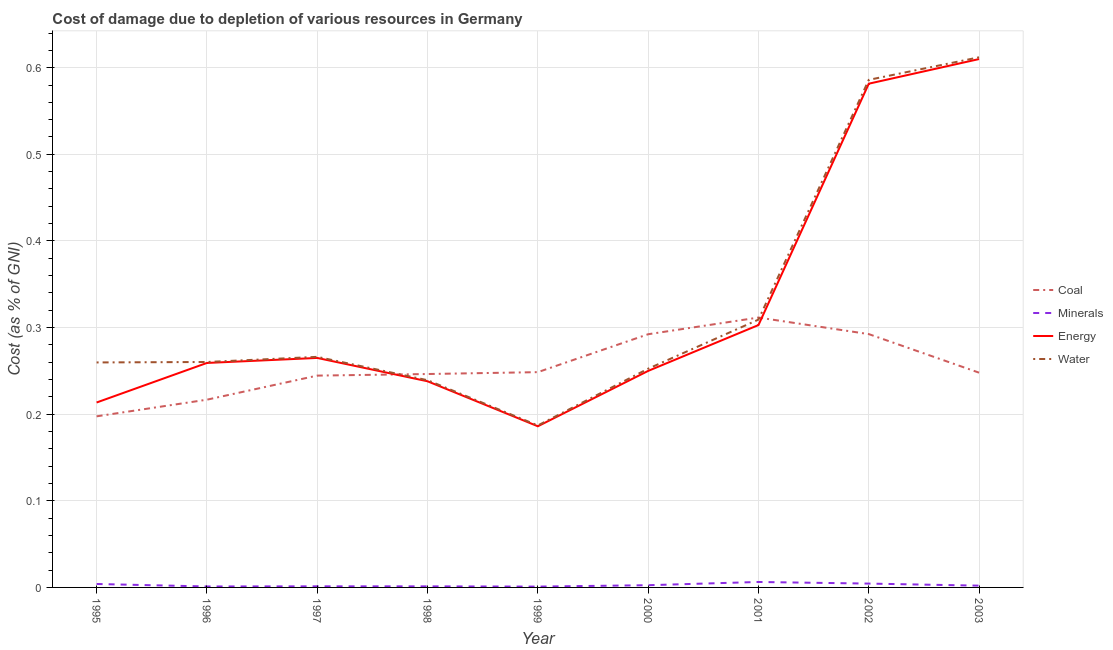Is the number of lines equal to the number of legend labels?
Make the answer very short. Yes. What is the cost of damage due to depletion of energy in 2001?
Your answer should be very brief. 0.3. Across all years, what is the maximum cost of damage due to depletion of water?
Your response must be concise. 0.61. Across all years, what is the minimum cost of damage due to depletion of coal?
Provide a short and direct response. 0.2. In which year was the cost of damage due to depletion of coal maximum?
Give a very brief answer. 2001. What is the total cost of damage due to depletion of coal in the graph?
Your answer should be compact. 2.3. What is the difference between the cost of damage due to depletion of water in 2001 and that in 2002?
Provide a short and direct response. -0.28. What is the difference between the cost of damage due to depletion of coal in 1997 and the cost of damage due to depletion of water in 1995?
Ensure brevity in your answer.  -0.02. What is the average cost of damage due to depletion of coal per year?
Your answer should be very brief. 0.26. In the year 1997, what is the difference between the cost of damage due to depletion of water and cost of damage due to depletion of energy?
Provide a succinct answer. 0. What is the ratio of the cost of damage due to depletion of coal in 1996 to that in 1997?
Keep it short and to the point. 0.89. Is the cost of damage due to depletion of coal in 1995 less than that in 2002?
Give a very brief answer. Yes. Is the difference between the cost of damage due to depletion of water in 2000 and 2003 greater than the difference between the cost of damage due to depletion of minerals in 2000 and 2003?
Offer a terse response. No. What is the difference between the highest and the second highest cost of damage due to depletion of water?
Your response must be concise. 0.03. What is the difference between the highest and the lowest cost of damage due to depletion of coal?
Your answer should be very brief. 0.11. In how many years, is the cost of damage due to depletion of minerals greater than the average cost of damage due to depletion of minerals taken over all years?
Your response must be concise. 3. Is the sum of the cost of damage due to depletion of energy in 2002 and 2003 greater than the maximum cost of damage due to depletion of minerals across all years?
Your answer should be very brief. Yes. Is it the case that in every year, the sum of the cost of damage due to depletion of water and cost of damage due to depletion of minerals is greater than the sum of cost of damage due to depletion of energy and cost of damage due to depletion of coal?
Keep it short and to the point. Yes. Is it the case that in every year, the sum of the cost of damage due to depletion of coal and cost of damage due to depletion of minerals is greater than the cost of damage due to depletion of energy?
Your answer should be compact. No. Does the cost of damage due to depletion of coal monotonically increase over the years?
Your answer should be very brief. No. How many lines are there?
Make the answer very short. 4. What is the difference between two consecutive major ticks on the Y-axis?
Make the answer very short. 0.1. Are the values on the major ticks of Y-axis written in scientific E-notation?
Provide a short and direct response. No. Does the graph contain grids?
Your response must be concise. Yes. Where does the legend appear in the graph?
Your answer should be very brief. Center right. How many legend labels are there?
Give a very brief answer. 4. How are the legend labels stacked?
Offer a very short reply. Vertical. What is the title of the graph?
Your answer should be very brief. Cost of damage due to depletion of various resources in Germany . Does "Social Insurance" appear as one of the legend labels in the graph?
Your answer should be very brief. No. What is the label or title of the X-axis?
Ensure brevity in your answer.  Year. What is the label or title of the Y-axis?
Make the answer very short. Cost (as % of GNI). What is the Cost (as % of GNI) of Coal in 1995?
Ensure brevity in your answer.  0.2. What is the Cost (as % of GNI) of Minerals in 1995?
Ensure brevity in your answer.  0. What is the Cost (as % of GNI) in Energy in 1995?
Your response must be concise. 0.21. What is the Cost (as % of GNI) of Water in 1995?
Your response must be concise. 0.26. What is the Cost (as % of GNI) of Coal in 1996?
Provide a short and direct response. 0.22. What is the Cost (as % of GNI) of Minerals in 1996?
Ensure brevity in your answer.  0. What is the Cost (as % of GNI) in Energy in 1996?
Offer a terse response. 0.26. What is the Cost (as % of GNI) in Water in 1996?
Ensure brevity in your answer.  0.26. What is the Cost (as % of GNI) in Coal in 1997?
Ensure brevity in your answer.  0.24. What is the Cost (as % of GNI) of Minerals in 1997?
Provide a succinct answer. 0. What is the Cost (as % of GNI) of Energy in 1997?
Offer a terse response. 0.26. What is the Cost (as % of GNI) in Water in 1997?
Your answer should be very brief. 0.27. What is the Cost (as % of GNI) of Coal in 1998?
Your answer should be compact. 0.25. What is the Cost (as % of GNI) of Minerals in 1998?
Provide a short and direct response. 0. What is the Cost (as % of GNI) in Energy in 1998?
Give a very brief answer. 0.24. What is the Cost (as % of GNI) in Water in 1998?
Give a very brief answer. 0.24. What is the Cost (as % of GNI) of Coal in 1999?
Your response must be concise. 0.25. What is the Cost (as % of GNI) in Minerals in 1999?
Provide a succinct answer. 0. What is the Cost (as % of GNI) of Energy in 1999?
Your answer should be very brief. 0.19. What is the Cost (as % of GNI) of Water in 1999?
Your answer should be very brief. 0.19. What is the Cost (as % of GNI) of Coal in 2000?
Offer a terse response. 0.29. What is the Cost (as % of GNI) of Minerals in 2000?
Ensure brevity in your answer.  0. What is the Cost (as % of GNI) of Energy in 2000?
Offer a very short reply. 0.25. What is the Cost (as % of GNI) of Water in 2000?
Make the answer very short. 0.25. What is the Cost (as % of GNI) in Coal in 2001?
Ensure brevity in your answer.  0.31. What is the Cost (as % of GNI) of Minerals in 2001?
Your response must be concise. 0.01. What is the Cost (as % of GNI) in Energy in 2001?
Give a very brief answer. 0.3. What is the Cost (as % of GNI) in Water in 2001?
Make the answer very short. 0.31. What is the Cost (as % of GNI) of Coal in 2002?
Provide a succinct answer. 0.29. What is the Cost (as % of GNI) in Minerals in 2002?
Keep it short and to the point. 0. What is the Cost (as % of GNI) in Energy in 2002?
Offer a terse response. 0.58. What is the Cost (as % of GNI) of Water in 2002?
Your answer should be very brief. 0.59. What is the Cost (as % of GNI) in Coal in 2003?
Keep it short and to the point. 0.25. What is the Cost (as % of GNI) in Minerals in 2003?
Make the answer very short. 0. What is the Cost (as % of GNI) of Energy in 2003?
Provide a succinct answer. 0.61. What is the Cost (as % of GNI) of Water in 2003?
Your answer should be very brief. 0.61. Across all years, what is the maximum Cost (as % of GNI) of Coal?
Your answer should be very brief. 0.31. Across all years, what is the maximum Cost (as % of GNI) in Minerals?
Your response must be concise. 0.01. Across all years, what is the maximum Cost (as % of GNI) of Energy?
Your response must be concise. 0.61. Across all years, what is the maximum Cost (as % of GNI) in Water?
Your response must be concise. 0.61. Across all years, what is the minimum Cost (as % of GNI) in Coal?
Your answer should be compact. 0.2. Across all years, what is the minimum Cost (as % of GNI) in Minerals?
Your answer should be compact. 0. Across all years, what is the minimum Cost (as % of GNI) of Energy?
Provide a succinct answer. 0.19. Across all years, what is the minimum Cost (as % of GNI) in Water?
Keep it short and to the point. 0.19. What is the total Cost (as % of GNI) in Coal in the graph?
Your answer should be very brief. 2.3. What is the total Cost (as % of GNI) of Minerals in the graph?
Make the answer very short. 0.02. What is the total Cost (as % of GNI) of Energy in the graph?
Your answer should be compact. 2.91. What is the total Cost (as % of GNI) of Water in the graph?
Make the answer very short. 2.97. What is the difference between the Cost (as % of GNI) of Coal in 1995 and that in 1996?
Provide a short and direct response. -0.02. What is the difference between the Cost (as % of GNI) in Minerals in 1995 and that in 1996?
Give a very brief answer. 0. What is the difference between the Cost (as % of GNI) of Energy in 1995 and that in 1996?
Provide a succinct answer. -0.05. What is the difference between the Cost (as % of GNI) of Water in 1995 and that in 1996?
Ensure brevity in your answer.  -0. What is the difference between the Cost (as % of GNI) of Coal in 1995 and that in 1997?
Offer a very short reply. -0.05. What is the difference between the Cost (as % of GNI) in Minerals in 1995 and that in 1997?
Your answer should be very brief. 0. What is the difference between the Cost (as % of GNI) in Energy in 1995 and that in 1997?
Offer a terse response. -0.05. What is the difference between the Cost (as % of GNI) in Water in 1995 and that in 1997?
Offer a terse response. -0.01. What is the difference between the Cost (as % of GNI) in Coal in 1995 and that in 1998?
Offer a terse response. -0.05. What is the difference between the Cost (as % of GNI) of Minerals in 1995 and that in 1998?
Keep it short and to the point. 0. What is the difference between the Cost (as % of GNI) of Energy in 1995 and that in 1998?
Offer a very short reply. -0.02. What is the difference between the Cost (as % of GNI) of Water in 1995 and that in 1998?
Provide a succinct answer. 0.02. What is the difference between the Cost (as % of GNI) in Coal in 1995 and that in 1999?
Provide a short and direct response. -0.05. What is the difference between the Cost (as % of GNI) in Minerals in 1995 and that in 1999?
Provide a short and direct response. 0. What is the difference between the Cost (as % of GNI) of Energy in 1995 and that in 1999?
Give a very brief answer. 0.03. What is the difference between the Cost (as % of GNI) of Water in 1995 and that in 1999?
Give a very brief answer. 0.07. What is the difference between the Cost (as % of GNI) in Coal in 1995 and that in 2000?
Make the answer very short. -0.09. What is the difference between the Cost (as % of GNI) in Minerals in 1995 and that in 2000?
Provide a short and direct response. 0. What is the difference between the Cost (as % of GNI) in Energy in 1995 and that in 2000?
Your response must be concise. -0.04. What is the difference between the Cost (as % of GNI) of Water in 1995 and that in 2000?
Ensure brevity in your answer.  0.01. What is the difference between the Cost (as % of GNI) of Coal in 1995 and that in 2001?
Your response must be concise. -0.11. What is the difference between the Cost (as % of GNI) in Minerals in 1995 and that in 2001?
Your answer should be very brief. -0. What is the difference between the Cost (as % of GNI) in Energy in 1995 and that in 2001?
Provide a succinct answer. -0.09. What is the difference between the Cost (as % of GNI) in Water in 1995 and that in 2001?
Ensure brevity in your answer.  -0.05. What is the difference between the Cost (as % of GNI) in Coal in 1995 and that in 2002?
Provide a short and direct response. -0.09. What is the difference between the Cost (as % of GNI) of Minerals in 1995 and that in 2002?
Provide a succinct answer. -0. What is the difference between the Cost (as % of GNI) of Energy in 1995 and that in 2002?
Keep it short and to the point. -0.37. What is the difference between the Cost (as % of GNI) in Water in 1995 and that in 2002?
Your response must be concise. -0.33. What is the difference between the Cost (as % of GNI) of Coal in 1995 and that in 2003?
Your answer should be compact. -0.05. What is the difference between the Cost (as % of GNI) in Minerals in 1995 and that in 2003?
Keep it short and to the point. 0. What is the difference between the Cost (as % of GNI) in Energy in 1995 and that in 2003?
Offer a terse response. -0.4. What is the difference between the Cost (as % of GNI) of Water in 1995 and that in 2003?
Your answer should be very brief. -0.35. What is the difference between the Cost (as % of GNI) in Coal in 1996 and that in 1997?
Your answer should be compact. -0.03. What is the difference between the Cost (as % of GNI) in Minerals in 1996 and that in 1997?
Keep it short and to the point. -0. What is the difference between the Cost (as % of GNI) of Energy in 1996 and that in 1997?
Offer a terse response. -0.01. What is the difference between the Cost (as % of GNI) in Water in 1996 and that in 1997?
Your response must be concise. -0.01. What is the difference between the Cost (as % of GNI) of Coal in 1996 and that in 1998?
Offer a terse response. -0.03. What is the difference between the Cost (as % of GNI) of Minerals in 1996 and that in 1998?
Offer a very short reply. -0. What is the difference between the Cost (as % of GNI) in Energy in 1996 and that in 1998?
Your response must be concise. 0.02. What is the difference between the Cost (as % of GNI) in Water in 1996 and that in 1998?
Make the answer very short. 0.02. What is the difference between the Cost (as % of GNI) of Coal in 1996 and that in 1999?
Your answer should be very brief. -0.03. What is the difference between the Cost (as % of GNI) in Energy in 1996 and that in 1999?
Your answer should be very brief. 0.07. What is the difference between the Cost (as % of GNI) in Water in 1996 and that in 1999?
Your answer should be very brief. 0.07. What is the difference between the Cost (as % of GNI) in Coal in 1996 and that in 2000?
Offer a very short reply. -0.08. What is the difference between the Cost (as % of GNI) of Minerals in 1996 and that in 2000?
Ensure brevity in your answer.  -0. What is the difference between the Cost (as % of GNI) of Energy in 1996 and that in 2000?
Provide a succinct answer. 0.01. What is the difference between the Cost (as % of GNI) of Water in 1996 and that in 2000?
Provide a short and direct response. 0.01. What is the difference between the Cost (as % of GNI) of Coal in 1996 and that in 2001?
Give a very brief answer. -0.09. What is the difference between the Cost (as % of GNI) in Minerals in 1996 and that in 2001?
Ensure brevity in your answer.  -0.01. What is the difference between the Cost (as % of GNI) of Energy in 1996 and that in 2001?
Your response must be concise. -0.04. What is the difference between the Cost (as % of GNI) of Water in 1996 and that in 2001?
Provide a succinct answer. -0.05. What is the difference between the Cost (as % of GNI) in Coal in 1996 and that in 2002?
Give a very brief answer. -0.08. What is the difference between the Cost (as % of GNI) in Minerals in 1996 and that in 2002?
Provide a succinct answer. -0. What is the difference between the Cost (as % of GNI) in Energy in 1996 and that in 2002?
Provide a short and direct response. -0.32. What is the difference between the Cost (as % of GNI) in Water in 1996 and that in 2002?
Provide a succinct answer. -0.33. What is the difference between the Cost (as % of GNI) of Coal in 1996 and that in 2003?
Provide a short and direct response. -0.03. What is the difference between the Cost (as % of GNI) of Minerals in 1996 and that in 2003?
Your response must be concise. -0. What is the difference between the Cost (as % of GNI) of Energy in 1996 and that in 2003?
Your answer should be very brief. -0.35. What is the difference between the Cost (as % of GNI) in Water in 1996 and that in 2003?
Provide a succinct answer. -0.35. What is the difference between the Cost (as % of GNI) in Coal in 1997 and that in 1998?
Offer a terse response. -0. What is the difference between the Cost (as % of GNI) of Energy in 1997 and that in 1998?
Give a very brief answer. 0.03. What is the difference between the Cost (as % of GNI) in Water in 1997 and that in 1998?
Provide a succinct answer. 0.03. What is the difference between the Cost (as % of GNI) of Coal in 1997 and that in 1999?
Make the answer very short. -0. What is the difference between the Cost (as % of GNI) in Energy in 1997 and that in 1999?
Make the answer very short. 0.08. What is the difference between the Cost (as % of GNI) of Water in 1997 and that in 1999?
Your answer should be very brief. 0.08. What is the difference between the Cost (as % of GNI) in Coal in 1997 and that in 2000?
Give a very brief answer. -0.05. What is the difference between the Cost (as % of GNI) of Minerals in 1997 and that in 2000?
Provide a short and direct response. -0. What is the difference between the Cost (as % of GNI) of Energy in 1997 and that in 2000?
Ensure brevity in your answer.  0.01. What is the difference between the Cost (as % of GNI) of Water in 1997 and that in 2000?
Provide a short and direct response. 0.01. What is the difference between the Cost (as % of GNI) of Coal in 1997 and that in 2001?
Your response must be concise. -0.07. What is the difference between the Cost (as % of GNI) in Minerals in 1997 and that in 2001?
Give a very brief answer. -0.01. What is the difference between the Cost (as % of GNI) in Energy in 1997 and that in 2001?
Provide a short and direct response. -0.04. What is the difference between the Cost (as % of GNI) of Water in 1997 and that in 2001?
Provide a succinct answer. -0.04. What is the difference between the Cost (as % of GNI) in Coal in 1997 and that in 2002?
Offer a very short reply. -0.05. What is the difference between the Cost (as % of GNI) of Minerals in 1997 and that in 2002?
Provide a short and direct response. -0. What is the difference between the Cost (as % of GNI) of Energy in 1997 and that in 2002?
Your answer should be compact. -0.32. What is the difference between the Cost (as % of GNI) in Water in 1997 and that in 2002?
Your answer should be compact. -0.32. What is the difference between the Cost (as % of GNI) in Coal in 1997 and that in 2003?
Keep it short and to the point. -0. What is the difference between the Cost (as % of GNI) in Minerals in 1997 and that in 2003?
Provide a short and direct response. -0. What is the difference between the Cost (as % of GNI) of Energy in 1997 and that in 2003?
Offer a terse response. -0.34. What is the difference between the Cost (as % of GNI) of Water in 1997 and that in 2003?
Your answer should be very brief. -0.35. What is the difference between the Cost (as % of GNI) of Coal in 1998 and that in 1999?
Ensure brevity in your answer.  -0. What is the difference between the Cost (as % of GNI) in Minerals in 1998 and that in 1999?
Your answer should be very brief. 0. What is the difference between the Cost (as % of GNI) in Energy in 1998 and that in 1999?
Make the answer very short. 0.05. What is the difference between the Cost (as % of GNI) in Water in 1998 and that in 1999?
Ensure brevity in your answer.  0.05. What is the difference between the Cost (as % of GNI) of Coal in 1998 and that in 2000?
Offer a very short reply. -0.05. What is the difference between the Cost (as % of GNI) in Minerals in 1998 and that in 2000?
Provide a succinct answer. -0. What is the difference between the Cost (as % of GNI) in Energy in 1998 and that in 2000?
Your response must be concise. -0.01. What is the difference between the Cost (as % of GNI) in Water in 1998 and that in 2000?
Your answer should be very brief. -0.01. What is the difference between the Cost (as % of GNI) of Coal in 1998 and that in 2001?
Offer a very short reply. -0.07. What is the difference between the Cost (as % of GNI) in Minerals in 1998 and that in 2001?
Give a very brief answer. -0.01. What is the difference between the Cost (as % of GNI) in Energy in 1998 and that in 2001?
Offer a terse response. -0.06. What is the difference between the Cost (as % of GNI) in Water in 1998 and that in 2001?
Ensure brevity in your answer.  -0.07. What is the difference between the Cost (as % of GNI) of Coal in 1998 and that in 2002?
Offer a terse response. -0.05. What is the difference between the Cost (as % of GNI) in Minerals in 1998 and that in 2002?
Your answer should be compact. -0. What is the difference between the Cost (as % of GNI) of Energy in 1998 and that in 2002?
Your answer should be compact. -0.34. What is the difference between the Cost (as % of GNI) in Water in 1998 and that in 2002?
Your answer should be compact. -0.35. What is the difference between the Cost (as % of GNI) of Coal in 1998 and that in 2003?
Your answer should be compact. -0. What is the difference between the Cost (as % of GNI) in Minerals in 1998 and that in 2003?
Offer a very short reply. -0. What is the difference between the Cost (as % of GNI) in Energy in 1998 and that in 2003?
Your answer should be compact. -0.37. What is the difference between the Cost (as % of GNI) in Water in 1998 and that in 2003?
Ensure brevity in your answer.  -0.37. What is the difference between the Cost (as % of GNI) of Coal in 1999 and that in 2000?
Your answer should be very brief. -0.04. What is the difference between the Cost (as % of GNI) of Minerals in 1999 and that in 2000?
Your response must be concise. -0. What is the difference between the Cost (as % of GNI) in Energy in 1999 and that in 2000?
Offer a very short reply. -0.06. What is the difference between the Cost (as % of GNI) in Water in 1999 and that in 2000?
Ensure brevity in your answer.  -0.07. What is the difference between the Cost (as % of GNI) in Coal in 1999 and that in 2001?
Your answer should be very brief. -0.06. What is the difference between the Cost (as % of GNI) in Minerals in 1999 and that in 2001?
Provide a succinct answer. -0.01. What is the difference between the Cost (as % of GNI) in Energy in 1999 and that in 2001?
Ensure brevity in your answer.  -0.12. What is the difference between the Cost (as % of GNI) of Water in 1999 and that in 2001?
Make the answer very short. -0.12. What is the difference between the Cost (as % of GNI) of Coal in 1999 and that in 2002?
Your answer should be compact. -0.04. What is the difference between the Cost (as % of GNI) of Minerals in 1999 and that in 2002?
Provide a short and direct response. -0. What is the difference between the Cost (as % of GNI) in Energy in 1999 and that in 2002?
Your response must be concise. -0.4. What is the difference between the Cost (as % of GNI) of Water in 1999 and that in 2002?
Offer a terse response. -0.4. What is the difference between the Cost (as % of GNI) in Coal in 1999 and that in 2003?
Your answer should be very brief. 0. What is the difference between the Cost (as % of GNI) of Minerals in 1999 and that in 2003?
Your response must be concise. -0. What is the difference between the Cost (as % of GNI) of Energy in 1999 and that in 2003?
Ensure brevity in your answer.  -0.42. What is the difference between the Cost (as % of GNI) of Water in 1999 and that in 2003?
Keep it short and to the point. -0.42. What is the difference between the Cost (as % of GNI) of Coal in 2000 and that in 2001?
Make the answer very short. -0.02. What is the difference between the Cost (as % of GNI) of Minerals in 2000 and that in 2001?
Ensure brevity in your answer.  -0. What is the difference between the Cost (as % of GNI) in Energy in 2000 and that in 2001?
Your answer should be compact. -0.05. What is the difference between the Cost (as % of GNI) in Water in 2000 and that in 2001?
Your answer should be compact. -0.06. What is the difference between the Cost (as % of GNI) of Coal in 2000 and that in 2002?
Your response must be concise. -0. What is the difference between the Cost (as % of GNI) in Minerals in 2000 and that in 2002?
Make the answer very short. -0. What is the difference between the Cost (as % of GNI) in Energy in 2000 and that in 2002?
Your answer should be very brief. -0.33. What is the difference between the Cost (as % of GNI) in Water in 2000 and that in 2002?
Provide a succinct answer. -0.33. What is the difference between the Cost (as % of GNI) of Coal in 2000 and that in 2003?
Provide a short and direct response. 0.04. What is the difference between the Cost (as % of GNI) in Energy in 2000 and that in 2003?
Make the answer very short. -0.36. What is the difference between the Cost (as % of GNI) of Water in 2000 and that in 2003?
Offer a terse response. -0.36. What is the difference between the Cost (as % of GNI) of Coal in 2001 and that in 2002?
Make the answer very short. 0.02. What is the difference between the Cost (as % of GNI) of Minerals in 2001 and that in 2002?
Offer a terse response. 0. What is the difference between the Cost (as % of GNI) in Energy in 2001 and that in 2002?
Your response must be concise. -0.28. What is the difference between the Cost (as % of GNI) in Water in 2001 and that in 2002?
Ensure brevity in your answer.  -0.28. What is the difference between the Cost (as % of GNI) in Coal in 2001 and that in 2003?
Keep it short and to the point. 0.06. What is the difference between the Cost (as % of GNI) in Minerals in 2001 and that in 2003?
Ensure brevity in your answer.  0. What is the difference between the Cost (as % of GNI) of Energy in 2001 and that in 2003?
Your response must be concise. -0.31. What is the difference between the Cost (as % of GNI) of Water in 2001 and that in 2003?
Make the answer very short. -0.3. What is the difference between the Cost (as % of GNI) of Coal in 2002 and that in 2003?
Your answer should be very brief. 0.04. What is the difference between the Cost (as % of GNI) of Minerals in 2002 and that in 2003?
Make the answer very short. 0. What is the difference between the Cost (as % of GNI) in Energy in 2002 and that in 2003?
Provide a succinct answer. -0.03. What is the difference between the Cost (as % of GNI) in Water in 2002 and that in 2003?
Your answer should be compact. -0.03. What is the difference between the Cost (as % of GNI) in Coal in 1995 and the Cost (as % of GNI) in Minerals in 1996?
Your answer should be compact. 0.2. What is the difference between the Cost (as % of GNI) of Coal in 1995 and the Cost (as % of GNI) of Energy in 1996?
Ensure brevity in your answer.  -0.06. What is the difference between the Cost (as % of GNI) of Coal in 1995 and the Cost (as % of GNI) of Water in 1996?
Offer a very short reply. -0.06. What is the difference between the Cost (as % of GNI) in Minerals in 1995 and the Cost (as % of GNI) in Energy in 1996?
Offer a terse response. -0.26. What is the difference between the Cost (as % of GNI) of Minerals in 1995 and the Cost (as % of GNI) of Water in 1996?
Offer a very short reply. -0.26. What is the difference between the Cost (as % of GNI) in Energy in 1995 and the Cost (as % of GNI) in Water in 1996?
Keep it short and to the point. -0.05. What is the difference between the Cost (as % of GNI) in Coal in 1995 and the Cost (as % of GNI) in Minerals in 1997?
Ensure brevity in your answer.  0.2. What is the difference between the Cost (as % of GNI) of Coal in 1995 and the Cost (as % of GNI) of Energy in 1997?
Give a very brief answer. -0.07. What is the difference between the Cost (as % of GNI) of Coal in 1995 and the Cost (as % of GNI) of Water in 1997?
Provide a succinct answer. -0.07. What is the difference between the Cost (as % of GNI) in Minerals in 1995 and the Cost (as % of GNI) in Energy in 1997?
Give a very brief answer. -0.26. What is the difference between the Cost (as % of GNI) in Minerals in 1995 and the Cost (as % of GNI) in Water in 1997?
Give a very brief answer. -0.26. What is the difference between the Cost (as % of GNI) of Energy in 1995 and the Cost (as % of GNI) of Water in 1997?
Give a very brief answer. -0.05. What is the difference between the Cost (as % of GNI) of Coal in 1995 and the Cost (as % of GNI) of Minerals in 1998?
Offer a terse response. 0.2. What is the difference between the Cost (as % of GNI) of Coal in 1995 and the Cost (as % of GNI) of Energy in 1998?
Your answer should be very brief. -0.04. What is the difference between the Cost (as % of GNI) in Coal in 1995 and the Cost (as % of GNI) in Water in 1998?
Keep it short and to the point. -0.04. What is the difference between the Cost (as % of GNI) in Minerals in 1995 and the Cost (as % of GNI) in Energy in 1998?
Offer a very short reply. -0.23. What is the difference between the Cost (as % of GNI) of Minerals in 1995 and the Cost (as % of GNI) of Water in 1998?
Make the answer very short. -0.24. What is the difference between the Cost (as % of GNI) in Energy in 1995 and the Cost (as % of GNI) in Water in 1998?
Make the answer very short. -0.03. What is the difference between the Cost (as % of GNI) in Coal in 1995 and the Cost (as % of GNI) in Minerals in 1999?
Keep it short and to the point. 0.2. What is the difference between the Cost (as % of GNI) in Coal in 1995 and the Cost (as % of GNI) in Energy in 1999?
Ensure brevity in your answer.  0.01. What is the difference between the Cost (as % of GNI) of Coal in 1995 and the Cost (as % of GNI) of Water in 1999?
Offer a terse response. 0.01. What is the difference between the Cost (as % of GNI) in Minerals in 1995 and the Cost (as % of GNI) in Energy in 1999?
Your response must be concise. -0.18. What is the difference between the Cost (as % of GNI) of Minerals in 1995 and the Cost (as % of GNI) of Water in 1999?
Provide a short and direct response. -0.18. What is the difference between the Cost (as % of GNI) in Energy in 1995 and the Cost (as % of GNI) in Water in 1999?
Provide a short and direct response. 0.03. What is the difference between the Cost (as % of GNI) in Coal in 1995 and the Cost (as % of GNI) in Minerals in 2000?
Your answer should be compact. 0.2. What is the difference between the Cost (as % of GNI) in Coal in 1995 and the Cost (as % of GNI) in Energy in 2000?
Make the answer very short. -0.05. What is the difference between the Cost (as % of GNI) of Coal in 1995 and the Cost (as % of GNI) of Water in 2000?
Your answer should be compact. -0.06. What is the difference between the Cost (as % of GNI) of Minerals in 1995 and the Cost (as % of GNI) of Energy in 2000?
Provide a succinct answer. -0.25. What is the difference between the Cost (as % of GNI) in Minerals in 1995 and the Cost (as % of GNI) in Water in 2000?
Offer a very short reply. -0.25. What is the difference between the Cost (as % of GNI) in Energy in 1995 and the Cost (as % of GNI) in Water in 2000?
Offer a very short reply. -0.04. What is the difference between the Cost (as % of GNI) in Coal in 1995 and the Cost (as % of GNI) in Minerals in 2001?
Provide a short and direct response. 0.19. What is the difference between the Cost (as % of GNI) in Coal in 1995 and the Cost (as % of GNI) in Energy in 2001?
Offer a very short reply. -0.11. What is the difference between the Cost (as % of GNI) in Coal in 1995 and the Cost (as % of GNI) in Water in 2001?
Your answer should be compact. -0.11. What is the difference between the Cost (as % of GNI) in Minerals in 1995 and the Cost (as % of GNI) in Energy in 2001?
Your answer should be very brief. -0.3. What is the difference between the Cost (as % of GNI) of Minerals in 1995 and the Cost (as % of GNI) of Water in 2001?
Offer a terse response. -0.31. What is the difference between the Cost (as % of GNI) of Energy in 1995 and the Cost (as % of GNI) of Water in 2001?
Your response must be concise. -0.1. What is the difference between the Cost (as % of GNI) in Coal in 1995 and the Cost (as % of GNI) in Minerals in 2002?
Ensure brevity in your answer.  0.19. What is the difference between the Cost (as % of GNI) in Coal in 1995 and the Cost (as % of GNI) in Energy in 2002?
Provide a short and direct response. -0.38. What is the difference between the Cost (as % of GNI) of Coal in 1995 and the Cost (as % of GNI) of Water in 2002?
Make the answer very short. -0.39. What is the difference between the Cost (as % of GNI) of Minerals in 1995 and the Cost (as % of GNI) of Energy in 2002?
Offer a very short reply. -0.58. What is the difference between the Cost (as % of GNI) of Minerals in 1995 and the Cost (as % of GNI) of Water in 2002?
Give a very brief answer. -0.58. What is the difference between the Cost (as % of GNI) in Energy in 1995 and the Cost (as % of GNI) in Water in 2002?
Offer a very short reply. -0.37. What is the difference between the Cost (as % of GNI) of Coal in 1995 and the Cost (as % of GNI) of Minerals in 2003?
Ensure brevity in your answer.  0.2. What is the difference between the Cost (as % of GNI) in Coal in 1995 and the Cost (as % of GNI) in Energy in 2003?
Ensure brevity in your answer.  -0.41. What is the difference between the Cost (as % of GNI) in Coal in 1995 and the Cost (as % of GNI) in Water in 2003?
Provide a short and direct response. -0.41. What is the difference between the Cost (as % of GNI) in Minerals in 1995 and the Cost (as % of GNI) in Energy in 2003?
Give a very brief answer. -0.61. What is the difference between the Cost (as % of GNI) of Minerals in 1995 and the Cost (as % of GNI) of Water in 2003?
Offer a very short reply. -0.61. What is the difference between the Cost (as % of GNI) in Energy in 1995 and the Cost (as % of GNI) in Water in 2003?
Keep it short and to the point. -0.4. What is the difference between the Cost (as % of GNI) in Coal in 1996 and the Cost (as % of GNI) in Minerals in 1997?
Keep it short and to the point. 0.22. What is the difference between the Cost (as % of GNI) in Coal in 1996 and the Cost (as % of GNI) in Energy in 1997?
Give a very brief answer. -0.05. What is the difference between the Cost (as % of GNI) in Coal in 1996 and the Cost (as % of GNI) in Water in 1997?
Provide a short and direct response. -0.05. What is the difference between the Cost (as % of GNI) in Minerals in 1996 and the Cost (as % of GNI) in Energy in 1997?
Make the answer very short. -0.26. What is the difference between the Cost (as % of GNI) in Minerals in 1996 and the Cost (as % of GNI) in Water in 1997?
Provide a short and direct response. -0.27. What is the difference between the Cost (as % of GNI) of Energy in 1996 and the Cost (as % of GNI) of Water in 1997?
Ensure brevity in your answer.  -0.01. What is the difference between the Cost (as % of GNI) in Coal in 1996 and the Cost (as % of GNI) in Minerals in 1998?
Ensure brevity in your answer.  0.22. What is the difference between the Cost (as % of GNI) of Coal in 1996 and the Cost (as % of GNI) of Energy in 1998?
Your answer should be very brief. -0.02. What is the difference between the Cost (as % of GNI) in Coal in 1996 and the Cost (as % of GNI) in Water in 1998?
Offer a terse response. -0.02. What is the difference between the Cost (as % of GNI) in Minerals in 1996 and the Cost (as % of GNI) in Energy in 1998?
Keep it short and to the point. -0.24. What is the difference between the Cost (as % of GNI) of Minerals in 1996 and the Cost (as % of GNI) of Water in 1998?
Keep it short and to the point. -0.24. What is the difference between the Cost (as % of GNI) in Energy in 1996 and the Cost (as % of GNI) in Water in 1998?
Ensure brevity in your answer.  0.02. What is the difference between the Cost (as % of GNI) of Coal in 1996 and the Cost (as % of GNI) of Minerals in 1999?
Offer a very short reply. 0.22. What is the difference between the Cost (as % of GNI) in Coal in 1996 and the Cost (as % of GNI) in Energy in 1999?
Your answer should be compact. 0.03. What is the difference between the Cost (as % of GNI) of Coal in 1996 and the Cost (as % of GNI) of Water in 1999?
Make the answer very short. 0.03. What is the difference between the Cost (as % of GNI) in Minerals in 1996 and the Cost (as % of GNI) in Energy in 1999?
Give a very brief answer. -0.18. What is the difference between the Cost (as % of GNI) of Minerals in 1996 and the Cost (as % of GNI) of Water in 1999?
Your answer should be compact. -0.19. What is the difference between the Cost (as % of GNI) of Energy in 1996 and the Cost (as % of GNI) of Water in 1999?
Your answer should be very brief. 0.07. What is the difference between the Cost (as % of GNI) of Coal in 1996 and the Cost (as % of GNI) of Minerals in 2000?
Offer a very short reply. 0.21. What is the difference between the Cost (as % of GNI) of Coal in 1996 and the Cost (as % of GNI) of Energy in 2000?
Give a very brief answer. -0.03. What is the difference between the Cost (as % of GNI) in Coal in 1996 and the Cost (as % of GNI) in Water in 2000?
Ensure brevity in your answer.  -0.04. What is the difference between the Cost (as % of GNI) of Minerals in 1996 and the Cost (as % of GNI) of Energy in 2000?
Provide a succinct answer. -0.25. What is the difference between the Cost (as % of GNI) of Minerals in 1996 and the Cost (as % of GNI) of Water in 2000?
Offer a very short reply. -0.25. What is the difference between the Cost (as % of GNI) of Energy in 1996 and the Cost (as % of GNI) of Water in 2000?
Give a very brief answer. 0.01. What is the difference between the Cost (as % of GNI) of Coal in 1996 and the Cost (as % of GNI) of Minerals in 2001?
Provide a short and direct response. 0.21. What is the difference between the Cost (as % of GNI) of Coal in 1996 and the Cost (as % of GNI) of Energy in 2001?
Your answer should be very brief. -0.09. What is the difference between the Cost (as % of GNI) of Coal in 1996 and the Cost (as % of GNI) of Water in 2001?
Your response must be concise. -0.09. What is the difference between the Cost (as % of GNI) in Minerals in 1996 and the Cost (as % of GNI) in Energy in 2001?
Make the answer very short. -0.3. What is the difference between the Cost (as % of GNI) of Minerals in 1996 and the Cost (as % of GNI) of Water in 2001?
Your answer should be compact. -0.31. What is the difference between the Cost (as % of GNI) in Coal in 1996 and the Cost (as % of GNI) in Minerals in 2002?
Provide a short and direct response. 0.21. What is the difference between the Cost (as % of GNI) in Coal in 1996 and the Cost (as % of GNI) in Energy in 2002?
Your answer should be very brief. -0.36. What is the difference between the Cost (as % of GNI) in Coal in 1996 and the Cost (as % of GNI) in Water in 2002?
Ensure brevity in your answer.  -0.37. What is the difference between the Cost (as % of GNI) of Minerals in 1996 and the Cost (as % of GNI) of Energy in 2002?
Your answer should be compact. -0.58. What is the difference between the Cost (as % of GNI) of Minerals in 1996 and the Cost (as % of GNI) of Water in 2002?
Your response must be concise. -0.58. What is the difference between the Cost (as % of GNI) of Energy in 1996 and the Cost (as % of GNI) of Water in 2002?
Ensure brevity in your answer.  -0.33. What is the difference between the Cost (as % of GNI) in Coal in 1996 and the Cost (as % of GNI) in Minerals in 2003?
Your answer should be very brief. 0.21. What is the difference between the Cost (as % of GNI) of Coal in 1996 and the Cost (as % of GNI) of Energy in 2003?
Keep it short and to the point. -0.39. What is the difference between the Cost (as % of GNI) in Coal in 1996 and the Cost (as % of GNI) in Water in 2003?
Your answer should be compact. -0.4. What is the difference between the Cost (as % of GNI) in Minerals in 1996 and the Cost (as % of GNI) in Energy in 2003?
Keep it short and to the point. -0.61. What is the difference between the Cost (as % of GNI) in Minerals in 1996 and the Cost (as % of GNI) in Water in 2003?
Give a very brief answer. -0.61. What is the difference between the Cost (as % of GNI) in Energy in 1996 and the Cost (as % of GNI) in Water in 2003?
Your answer should be compact. -0.35. What is the difference between the Cost (as % of GNI) of Coal in 1997 and the Cost (as % of GNI) of Minerals in 1998?
Provide a short and direct response. 0.24. What is the difference between the Cost (as % of GNI) in Coal in 1997 and the Cost (as % of GNI) in Energy in 1998?
Ensure brevity in your answer.  0.01. What is the difference between the Cost (as % of GNI) in Coal in 1997 and the Cost (as % of GNI) in Water in 1998?
Your answer should be compact. 0.01. What is the difference between the Cost (as % of GNI) in Minerals in 1997 and the Cost (as % of GNI) in Energy in 1998?
Provide a succinct answer. -0.24. What is the difference between the Cost (as % of GNI) of Minerals in 1997 and the Cost (as % of GNI) of Water in 1998?
Offer a very short reply. -0.24. What is the difference between the Cost (as % of GNI) of Energy in 1997 and the Cost (as % of GNI) of Water in 1998?
Your response must be concise. 0.03. What is the difference between the Cost (as % of GNI) in Coal in 1997 and the Cost (as % of GNI) in Minerals in 1999?
Provide a succinct answer. 0.24. What is the difference between the Cost (as % of GNI) in Coal in 1997 and the Cost (as % of GNI) in Energy in 1999?
Your response must be concise. 0.06. What is the difference between the Cost (as % of GNI) of Coal in 1997 and the Cost (as % of GNI) of Water in 1999?
Provide a short and direct response. 0.06. What is the difference between the Cost (as % of GNI) of Minerals in 1997 and the Cost (as % of GNI) of Energy in 1999?
Keep it short and to the point. -0.18. What is the difference between the Cost (as % of GNI) in Minerals in 1997 and the Cost (as % of GNI) in Water in 1999?
Offer a very short reply. -0.19. What is the difference between the Cost (as % of GNI) in Energy in 1997 and the Cost (as % of GNI) in Water in 1999?
Make the answer very short. 0.08. What is the difference between the Cost (as % of GNI) of Coal in 1997 and the Cost (as % of GNI) of Minerals in 2000?
Keep it short and to the point. 0.24. What is the difference between the Cost (as % of GNI) in Coal in 1997 and the Cost (as % of GNI) in Energy in 2000?
Your answer should be compact. -0.01. What is the difference between the Cost (as % of GNI) in Coal in 1997 and the Cost (as % of GNI) in Water in 2000?
Give a very brief answer. -0.01. What is the difference between the Cost (as % of GNI) of Minerals in 1997 and the Cost (as % of GNI) of Energy in 2000?
Offer a very short reply. -0.25. What is the difference between the Cost (as % of GNI) of Minerals in 1997 and the Cost (as % of GNI) of Water in 2000?
Ensure brevity in your answer.  -0.25. What is the difference between the Cost (as % of GNI) of Energy in 1997 and the Cost (as % of GNI) of Water in 2000?
Offer a terse response. 0.01. What is the difference between the Cost (as % of GNI) in Coal in 1997 and the Cost (as % of GNI) in Minerals in 2001?
Keep it short and to the point. 0.24. What is the difference between the Cost (as % of GNI) of Coal in 1997 and the Cost (as % of GNI) of Energy in 2001?
Keep it short and to the point. -0.06. What is the difference between the Cost (as % of GNI) of Coal in 1997 and the Cost (as % of GNI) of Water in 2001?
Your answer should be compact. -0.06. What is the difference between the Cost (as % of GNI) in Minerals in 1997 and the Cost (as % of GNI) in Energy in 2001?
Your answer should be compact. -0.3. What is the difference between the Cost (as % of GNI) in Minerals in 1997 and the Cost (as % of GNI) in Water in 2001?
Offer a very short reply. -0.31. What is the difference between the Cost (as % of GNI) of Energy in 1997 and the Cost (as % of GNI) of Water in 2001?
Offer a terse response. -0.04. What is the difference between the Cost (as % of GNI) in Coal in 1997 and the Cost (as % of GNI) in Minerals in 2002?
Ensure brevity in your answer.  0.24. What is the difference between the Cost (as % of GNI) in Coal in 1997 and the Cost (as % of GNI) in Energy in 2002?
Offer a very short reply. -0.34. What is the difference between the Cost (as % of GNI) of Coal in 1997 and the Cost (as % of GNI) of Water in 2002?
Your answer should be compact. -0.34. What is the difference between the Cost (as % of GNI) in Minerals in 1997 and the Cost (as % of GNI) in Energy in 2002?
Ensure brevity in your answer.  -0.58. What is the difference between the Cost (as % of GNI) of Minerals in 1997 and the Cost (as % of GNI) of Water in 2002?
Give a very brief answer. -0.58. What is the difference between the Cost (as % of GNI) of Energy in 1997 and the Cost (as % of GNI) of Water in 2002?
Provide a succinct answer. -0.32. What is the difference between the Cost (as % of GNI) of Coal in 1997 and the Cost (as % of GNI) of Minerals in 2003?
Provide a succinct answer. 0.24. What is the difference between the Cost (as % of GNI) of Coal in 1997 and the Cost (as % of GNI) of Energy in 2003?
Keep it short and to the point. -0.37. What is the difference between the Cost (as % of GNI) in Coal in 1997 and the Cost (as % of GNI) in Water in 2003?
Your answer should be very brief. -0.37. What is the difference between the Cost (as % of GNI) of Minerals in 1997 and the Cost (as % of GNI) of Energy in 2003?
Make the answer very short. -0.61. What is the difference between the Cost (as % of GNI) in Minerals in 1997 and the Cost (as % of GNI) in Water in 2003?
Keep it short and to the point. -0.61. What is the difference between the Cost (as % of GNI) in Energy in 1997 and the Cost (as % of GNI) in Water in 2003?
Keep it short and to the point. -0.35. What is the difference between the Cost (as % of GNI) of Coal in 1998 and the Cost (as % of GNI) of Minerals in 1999?
Keep it short and to the point. 0.25. What is the difference between the Cost (as % of GNI) of Coal in 1998 and the Cost (as % of GNI) of Energy in 1999?
Offer a very short reply. 0.06. What is the difference between the Cost (as % of GNI) in Coal in 1998 and the Cost (as % of GNI) in Water in 1999?
Keep it short and to the point. 0.06. What is the difference between the Cost (as % of GNI) in Minerals in 1998 and the Cost (as % of GNI) in Energy in 1999?
Offer a terse response. -0.18. What is the difference between the Cost (as % of GNI) of Minerals in 1998 and the Cost (as % of GNI) of Water in 1999?
Give a very brief answer. -0.19. What is the difference between the Cost (as % of GNI) in Energy in 1998 and the Cost (as % of GNI) in Water in 1999?
Your answer should be very brief. 0.05. What is the difference between the Cost (as % of GNI) in Coal in 1998 and the Cost (as % of GNI) in Minerals in 2000?
Offer a terse response. 0.24. What is the difference between the Cost (as % of GNI) in Coal in 1998 and the Cost (as % of GNI) in Energy in 2000?
Keep it short and to the point. -0. What is the difference between the Cost (as % of GNI) of Coal in 1998 and the Cost (as % of GNI) of Water in 2000?
Offer a terse response. -0.01. What is the difference between the Cost (as % of GNI) of Minerals in 1998 and the Cost (as % of GNI) of Energy in 2000?
Keep it short and to the point. -0.25. What is the difference between the Cost (as % of GNI) in Minerals in 1998 and the Cost (as % of GNI) in Water in 2000?
Your response must be concise. -0.25. What is the difference between the Cost (as % of GNI) of Energy in 1998 and the Cost (as % of GNI) of Water in 2000?
Offer a very short reply. -0.01. What is the difference between the Cost (as % of GNI) of Coal in 1998 and the Cost (as % of GNI) of Minerals in 2001?
Your answer should be very brief. 0.24. What is the difference between the Cost (as % of GNI) in Coal in 1998 and the Cost (as % of GNI) in Energy in 2001?
Give a very brief answer. -0.06. What is the difference between the Cost (as % of GNI) in Coal in 1998 and the Cost (as % of GNI) in Water in 2001?
Your answer should be compact. -0.06. What is the difference between the Cost (as % of GNI) of Minerals in 1998 and the Cost (as % of GNI) of Energy in 2001?
Offer a very short reply. -0.3. What is the difference between the Cost (as % of GNI) in Minerals in 1998 and the Cost (as % of GNI) in Water in 2001?
Offer a very short reply. -0.31. What is the difference between the Cost (as % of GNI) of Energy in 1998 and the Cost (as % of GNI) of Water in 2001?
Make the answer very short. -0.07. What is the difference between the Cost (as % of GNI) of Coal in 1998 and the Cost (as % of GNI) of Minerals in 2002?
Your response must be concise. 0.24. What is the difference between the Cost (as % of GNI) in Coal in 1998 and the Cost (as % of GNI) in Energy in 2002?
Your answer should be very brief. -0.34. What is the difference between the Cost (as % of GNI) in Coal in 1998 and the Cost (as % of GNI) in Water in 2002?
Make the answer very short. -0.34. What is the difference between the Cost (as % of GNI) of Minerals in 1998 and the Cost (as % of GNI) of Energy in 2002?
Offer a very short reply. -0.58. What is the difference between the Cost (as % of GNI) of Minerals in 1998 and the Cost (as % of GNI) of Water in 2002?
Your answer should be compact. -0.58. What is the difference between the Cost (as % of GNI) of Energy in 1998 and the Cost (as % of GNI) of Water in 2002?
Provide a succinct answer. -0.35. What is the difference between the Cost (as % of GNI) in Coal in 1998 and the Cost (as % of GNI) in Minerals in 2003?
Provide a succinct answer. 0.24. What is the difference between the Cost (as % of GNI) of Coal in 1998 and the Cost (as % of GNI) of Energy in 2003?
Keep it short and to the point. -0.36. What is the difference between the Cost (as % of GNI) in Coal in 1998 and the Cost (as % of GNI) in Water in 2003?
Provide a succinct answer. -0.37. What is the difference between the Cost (as % of GNI) of Minerals in 1998 and the Cost (as % of GNI) of Energy in 2003?
Provide a succinct answer. -0.61. What is the difference between the Cost (as % of GNI) of Minerals in 1998 and the Cost (as % of GNI) of Water in 2003?
Offer a terse response. -0.61. What is the difference between the Cost (as % of GNI) of Energy in 1998 and the Cost (as % of GNI) of Water in 2003?
Offer a very short reply. -0.37. What is the difference between the Cost (as % of GNI) in Coal in 1999 and the Cost (as % of GNI) in Minerals in 2000?
Your answer should be very brief. 0.25. What is the difference between the Cost (as % of GNI) in Coal in 1999 and the Cost (as % of GNI) in Energy in 2000?
Ensure brevity in your answer.  -0. What is the difference between the Cost (as % of GNI) in Coal in 1999 and the Cost (as % of GNI) in Water in 2000?
Provide a succinct answer. -0. What is the difference between the Cost (as % of GNI) in Minerals in 1999 and the Cost (as % of GNI) in Energy in 2000?
Provide a short and direct response. -0.25. What is the difference between the Cost (as % of GNI) in Minerals in 1999 and the Cost (as % of GNI) in Water in 2000?
Give a very brief answer. -0.25. What is the difference between the Cost (as % of GNI) in Energy in 1999 and the Cost (as % of GNI) in Water in 2000?
Provide a succinct answer. -0.07. What is the difference between the Cost (as % of GNI) in Coal in 1999 and the Cost (as % of GNI) in Minerals in 2001?
Give a very brief answer. 0.24. What is the difference between the Cost (as % of GNI) in Coal in 1999 and the Cost (as % of GNI) in Energy in 2001?
Keep it short and to the point. -0.05. What is the difference between the Cost (as % of GNI) of Coal in 1999 and the Cost (as % of GNI) of Water in 2001?
Provide a succinct answer. -0.06. What is the difference between the Cost (as % of GNI) in Minerals in 1999 and the Cost (as % of GNI) in Energy in 2001?
Make the answer very short. -0.3. What is the difference between the Cost (as % of GNI) in Minerals in 1999 and the Cost (as % of GNI) in Water in 2001?
Offer a very short reply. -0.31. What is the difference between the Cost (as % of GNI) in Energy in 1999 and the Cost (as % of GNI) in Water in 2001?
Your response must be concise. -0.12. What is the difference between the Cost (as % of GNI) of Coal in 1999 and the Cost (as % of GNI) of Minerals in 2002?
Offer a very short reply. 0.24. What is the difference between the Cost (as % of GNI) of Coal in 1999 and the Cost (as % of GNI) of Energy in 2002?
Your response must be concise. -0.33. What is the difference between the Cost (as % of GNI) of Coal in 1999 and the Cost (as % of GNI) of Water in 2002?
Give a very brief answer. -0.34. What is the difference between the Cost (as % of GNI) of Minerals in 1999 and the Cost (as % of GNI) of Energy in 2002?
Provide a succinct answer. -0.58. What is the difference between the Cost (as % of GNI) in Minerals in 1999 and the Cost (as % of GNI) in Water in 2002?
Ensure brevity in your answer.  -0.58. What is the difference between the Cost (as % of GNI) of Energy in 1999 and the Cost (as % of GNI) of Water in 2002?
Keep it short and to the point. -0.4. What is the difference between the Cost (as % of GNI) in Coal in 1999 and the Cost (as % of GNI) in Minerals in 2003?
Provide a short and direct response. 0.25. What is the difference between the Cost (as % of GNI) in Coal in 1999 and the Cost (as % of GNI) in Energy in 2003?
Provide a succinct answer. -0.36. What is the difference between the Cost (as % of GNI) of Coal in 1999 and the Cost (as % of GNI) of Water in 2003?
Offer a terse response. -0.36. What is the difference between the Cost (as % of GNI) in Minerals in 1999 and the Cost (as % of GNI) in Energy in 2003?
Offer a very short reply. -0.61. What is the difference between the Cost (as % of GNI) in Minerals in 1999 and the Cost (as % of GNI) in Water in 2003?
Give a very brief answer. -0.61. What is the difference between the Cost (as % of GNI) in Energy in 1999 and the Cost (as % of GNI) in Water in 2003?
Ensure brevity in your answer.  -0.43. What is the difference between the Cost (as % of GNI) of Coal in 2000 and the Cost (as % of GNI) of Minerals in 2001?
Provide a short and direct response. 0.29. What is the difference between the Cost (as % of GNI) of Coal in 2000 and the Cost (as % of GNI) of Energy in 2001?
Your response must be concise. -0.01. What is the difference between the Cost (as % of GNI) in Coal in 2000 and the Cost (as % of GNI) in Water in 2001?
Your answer should be very brief. -0.02. What is the difference between the Cost (as % of GNI) in Minerals in 2000 and the Cost (as % of GNI) in Energy in 2001?
Keep it short and to the point. -0.3. What is the difference between the Cost (as % of GNI) of Minerals in 2000 and the Cost (as % of GNI) of Water in 2001?
Your response must be concise. -0.31. What is the difference between the Cost (as % of GNI) of Energy in 2000 and the Cost (as % of GNI) of Water in 2001?
Make the answer very short. -0.06. What is the difference between the Cost (as % of GNI) of Coal in 2000 and the Cost (as % of GNI) of Minerals in 2002?
Offer a terse response. 0.29. What is the difference between the Cost (as % of GNI) in Coal in 2000 and the Cost (as % of GNI) in Energy in 2002?
Provide a succinct answer. -0.29. What is the difference between the Cost (as % of GNI) of Coal in 2000 and the Cost (as % of GNI) of Water in 2002?
Your response must be concise. -0.29. What is the difference between the Cost (as % of GNI) in Minerals in 2000 and the Cost (as % of GNI) in Energy in 2002?
Provide a short and direct response. -0.58. What is the difference between the Cost (as % of GNI) of Minerals in 2000 and the Cost (as % of GNI) of Water in 2002?
Keep it short and to the point. -0.58. What is the difference between the Cost (as % of GNI) of Energy in 2000 and the Cost (as % of GNI) of Water in 2002?
Your response must be concise. -0.34. What is the difference between the Cost (as % of GNI) of Coal in 2000 and the Cost (as % of GNI) of Minerals in 2003?
Your answer should be compact. 0.29. What is the difference between the Cost (as % of GNI) of Coal in 2000 and the Cost (as % of GNI) of Energy in 2003?
Keep it short and to the point. -0.32. What is the difference between the Cost (as % of GNI) of Coal in 2000 and the Cost (as % of GNI) of Water in 2003?
Keep it short and to the point. -0.32. What is the difference between the Cost (as % of GNI) in Minerals in 2000 and the Cost (as % of GNI) in Energy in 2003?
Give a very brief answer. -0.61. What is the difference between the Cost (as % of GNI) of Minerals in 2000 and the Cost (as % of GNI) of Water in 2003?
Provide a succinct answer. -0.61. What is the difference between the Cost (as % of GNI) in Energy in 2000 and the Cost (as % of GNI) in Water in 2003?
Provide a succinct answer. -0.36. What is the difference between the Cost (as % of GNI) of Coal in 2001 and the Cost (as % of GNI) of Minerals in 2002?
Give a very brief answer. 0.31. What is the difference between the Cost (as % of GNI) in Coal in 2001 and the Cost (as % of GNI) in Energy in 2002?
Offer a very short reply. -0.27. What is the difference between the Cost (as % of GNI) in Coal in 2001 and the Cost (as % of GNI) in Water in 2002?
Ensure brevity in your answer.  -0.27. What is the difference between the Cost (as % of GNI) in Minerals in 2001 and the Cost (as % of GNI) in Energy in 2002?
Provide a succinct answer. -0.58. What is the difference between the Cost (as % of GNI) of Minerals in 2001 and the Cost (as % of GNI) of Water in 2002?
Provide a short and direct response. -0.58. What is the difference between the Cost (as % of GNI) of Energy in 2001 and the Cost (as % of GNI) of Water in 2002?
Your answer should be very brief. -0.28. What is the difference between the Cost (as % of GNI) in Coal in 2001 and the Cost (as % of GNI) in Minerals in 2003?
Offer a terse response. 0.31. What is the difference between the Cost (as % of GNI) of Coal in 2001 and the Cost (as % of GNI) of Energy in 2003?
Your answer should be compact. -0.3. What is the difference between the Cost (as % of GNI) of Coal in 2001 and the Cost (as % of GNI) of Water in 2003?
Ensure brevity in your answer.  -0.3. What is the difference between the Cost (as % of GNI) of Minerals in 2001 and the Cost (as % of GNI) of Energy in 2003?
Provide a short and direct response. -0.6. What is the difference between the Cost (as % of GNI) of Minerals in 2001 and the Cost (as % of GNI) of Water in 2003?
Offer a very short reply. -0.61. What is the difference between the Cost (as % of GNI) of Energy in 2001 and the Cost (as % of GNI) of Water in 2003?
Ensure brevity in your answer.  -0.31. What is the difference between the Cost (as % of GNI) in Coal in 2002 and the Cost (as % of GNI) in Minerals in 2003?
Offer a terse response. 0.29. What is the difference between the Cost (as % of GNI) in Coal in 2002 and the Cost (as % of GNI) in Energy in 2003?
Your answer should be very brief. -0.32. What is the difference between the Cost (as % of GNI) in Coal in 2002 and the Cost (as % of GNI) in Water in 2003?
Your answer should be very brief. -0.32. What is the difference between the Cost (as % of GNI) of Minerals in 2002 and the Cost (as % of GNI) of Energy in 2003?
Provide a short and direct response. -0.61. What is the difference between the Cost (as % of GNI) of Minerals in 2002 and the Cost (as % of GNI) of Water in 2003?
Offer a terse response. -0.61. What is the difference between the Cost (as % of GNI) in Energy in 2002 and the Cost (as % of GNI) in Water in 2003?
Your answer should be very brief. -0.03. What is the average Cost (as % of GNI) in Coal per year?
Give a very brief answer. 0.26. What is the average Cost (as % of GNI) in Minerals per year?
Give a very brief answer. 0. What is the average Cost (as % of GNI) of Energy per year?
Provide a succinct answer. 0.32. What is the average Cost (as % of GNI) in Water per year?
Offer a very short reply. 0.33. In the year 1995, what is the difference between the Cost (as % of GNI) in Coal and Cost (as % of GNI) in Minerals?
Offer a terse response. 0.19. In the year 1995, what is the difference between the Cost (as % of GNI) in Coal and Cost (as % of GNI) in Energy?
Your answer should be very brief. -0.02. In the year 1995, what is the difference between the Cost (as % of GNI) in Coal and Cost (as % of GNI) in Water?
Your answer should be compact. -0.06. In the year 1995, what is the difference between the Cost (as % of GNI) of Minerals and Cost (as % of GNI) of Energy?
Your response must be concise. -0.21. In the year 1995, what is the difference between the Cost (as % of GNI) in Minerals and Cost (as % of GNI) in Water?
Your answer should be very brief. -0.26. In the year 1995, what is the difference between the Cost (as % of GNI) of Energy and Cost (as % of GNI) of Water?
Give a very brief answer. -0.05. In the year 1996, what is the difference between the Cost (as % of GNI) of Coal and Cost (as % of GNI) of Minerals?
Give a very brief answer. 0.22. In the year 1996, what is the difference between the Cost (as % of GNI) in Coal and Cost (as % of GNI) in Energy?
Ensure brevity in your answer.  -0.04. In the year 1996, what is the difference between the Cost (as % of GNI) of Coal and Cost (as % of GNI) of Water?
Make the answer very short. -0.04. In the year 1996, what is the difference between the Cost (as % of GNI) in Minerals and Cost (as % of GNI) in Energy?
Your answer should be very brief. -0.26. In the year 1996, what is the difference between the Cost (as % of GNI) of Minerals and Cost (as % of GNI) of Water?
Your answer should be compact. -0.26. In the year 1996, what is the difference between the Cost (as % of GNI) of Energy and Cost (as % of GNI) of Water?
Your response must be concise. -0. In the year 1997, what is the difference between the Cost (as % of GNI) in Coal and Cost (as % of GNI) in Minerals?
Ensure brevity in your answer.  0.24. In the year 1997, what is the difference between the Cost (as % of GNI) of Coal and Cost (as % of GNI) of Energy?
Provide a short and direct response. -0.02. In the year 1997, what is the difference between the Cost (as % of GNI) in Coal and Cost (as % of GNI) in Water?
Keep it short and to the point. -0.02. In the year 1997, what is the difference between the Cost (as % of GNI) of Minerals and Cost (as % of GNI) of Energy?
Your response must be concise. -0.26. In the year 1997, what is the difference between the Cost (as % of GNI) of Minerals and Cost (as % of GNI) of Water?
Give a very brief answer. -0.26. In the year 1997, what is the difference between the Cost (as % of GNI) of Energy and Cost (as % of GNI) of Water?
Provide a short and direct response. -0. In the year 1998, what is the difference between the Cost (as % of GNI) of Coal and Cost (as % of GNI) of Minerals?
Offer a very short reply. 0.25. In the year 1998, what is the difference between the Cost (as % of GNI) of Coal and Cost (as % of GNI) of Energy?
Provide a short and direct response. 0.01. In the year 1998, what is the difference between the Cost (as % of GNI) in Coal and Cost (as % of GNI) in Water?
Offer a terse response. 0.01. In the year 1998, what is the difference between the Cost (as % of GNI) in Minerals and Cost (as % of GNI) in Energy?
Provide a short and direct response. -0.24. In the year 1998, what is the difference between the Cost (as % of GNI) in Minerals and Cost (as % of GNI) in Water?
Keep it short and to the point. -0.24. In the year 1998, what is the difference between the Cost (as % of GNI) in Energy and Cost (as % of GNI) in Water?
Provide a short and direct response. -0. In the year 1999, what is the difference between the Cost (as % of GNI) in Coal and Cost (as % of GNI) in Minerals?
Your answer should be very brief. 0.25. In the year 1999, what is the difference between the Cost (as % of GNI) in Coal and Cost (as % of GNI) in Energy?
Make the answer very short. 0.06. In the year 1999, what is the difference between the Cost (as % of GNI) in Coal and Cost (as % of GNI) in Water?
Your answer should be very brief. 0.06. In the year 1999, what is the difference between the Cost (as % of GNI) of Minerals and Cost (as % of GNI) of Energy?
Offer a very short reply. -0.19. In the year 1999, what is the difference between the Cost (as % of GNI) in Minerals and Cost (as % of GNI) in Water?
Keep it short and to the point. -0.19. In the year 1999, what is the difference between the Cost (as % of GNI) in Energy and Cost (as % of GNI) in Water?
Provide a short and direct response. -0. In the year 2000, what is the difference between the Cost (as % of GNI) in Coal and Cost (as % of GNI) in Minerals?
Your answer should be very brief. 0.29. In the year 2000, what is the difference between the Cost (as % of GNI) in Coal and Cost (as % of GNI) in Energy?
Give a very brief answer. 0.04. In the year 2000, what is the difference between the Cost (as % of GNI) in Coal and Cost (as % of GNI) in Water?
Provide a succinct answer. 0.04. In the year 2000, what is the difference between the Cost (as % of GNI) of Minerals and Cost (as % of GNI) of Energy?
Ensure brevity in your answer.  -0.25. In the year 2000, what is the difference between the Cost (as % of GNI) of Minerals and Cost (as % of GNI) of Water?
Provide a short and direct response. -0.25. In the year 2000, what is the difference between the Cost (as % of GNI) of Energy and Cost (as % of GNI) of Water?
Provide a short and direct response. -0. In the year 2001, what is the difference between the Cost (as % of GNI) in Coal and Cost (as % of GNI) in Minerals?
Give a very brief answer. 0.31. In the year 2001, what is the difference between the Cost (as % of GNI) in Coal and Cost (as % of GNI) in Energy?
Your answer should be compact. 0.01. In the year 2001, what is the difference between the Cost (as % of GNI) in Coal and Cost (as % of GNI) in Water?
Your answer should be very brief. 0. In the year 2001, what is the difference between the Cost (as % of GNI) of Minerals and Cost (as % of GNI) of Energy?
Your answer should be very brief. -0.3. In the year 2001, what is the difference between the Cost (as % of GNI) in Minerals and Cost (as % of GNI) in Water?
Give a very brief answer. -0.3. In the year 2001, what is the difference between the Cost (as % of GNI) in Energy and Cost (as % of GNI) in Water?
Your response must be concise. -0.01. In the year 2002, what is the difference between the Cost (as % of GNI) of Coal and Cost (as % of GNI) of Minerals?
Give a very brief answer. 0.29. In the year 2002, what is the difference between the Cost (as % of GNI) of Coal and Cost (as % of GNI) of Energy?
Ensure brevity in your answer.  -0.29. In the year 2002, what is the difference between the Cost (as % of GNI) in Coal and Cost (as % of GNI) in Water?
Provide a short and direct response. -0.29. In the year 2002, what is the difference between the Cost (as % of GNI) of Minerals and Cost (as % of GNI) of Energy?
Provide a short and direct response. -0.58. In the year 2002, what is the difference between the Cost (as % of GNI) in Minerals and Cost (as % of GNI) in Water?
Ensure brevity in your answer.  -0.58. In the year 2002, what is the difference between the Cost (as % of GNI) of Energy and Cost (as % of GNI) of Water?
Ensure brevity in your answer.  -0. In the year 2003, what is the difference between the Cost (as % of GNI) of Coal and Cost (as % of GNI) of Minerals?
Your answer should be very brief. 0.25. In the year 2003, what is the difference between the Cost (as % of GNI) in Coal and Cost (as % of GNI) in Energy?
Your answer should be compact. -0.36. In the year 2003, what is the difference between the Cost (as % of GNI) of Coal and Cost (as % of GNI) of Water?
Ensure brevity in your answer.  -0.36. In the year 2003, what is the difference between the Cost (as % of GNI) of Minerals and Cost (as % of GNI) of Energy?
Offer a terse response. -0.61. In the year 2003, what is the difference between the Cost (as % of GNI) in Minerals and Cost (as % of GNI) in Water?
Give a very brief answer. -0.61. In the year 2003, what is the difference between the Cost (as % of GNI) of Energy and Cost (as % of GNI) of Water?
Ensure brevity in your answer.  -0. What is the ratio of the Cost (as % of GNI) of Coal in 1995 to that in 1996?
Your answer should be very brief. 0.91. What is the ratio of the Cost (as % of GNI) in Minerals in 1995 to that in 1996?
Provide a short and direct response. 3.59. What is the ratio of the Cost (as % of GNI) in Energy in 1995 to that in 1996?
Provide a short and direct response. 0.82. What is the ratio of the Cost (as % of GNI) in Coal in 1995 to that in 1997?
Keep it short and to the point. 0.81. What is the ratio of the Cost (as % of GNI) of Minerals in 1995 to that in 1997?
Provide a succinct answer. 3.14. What is the ratio of the Cost (as % of GNI) in Energy in 1995 to that in 1997?
Provide a succinct answer. 0.81. What is the ratio of the Cost (as % of GNI) in Water in 1995 to that in 1997?
Your answer should be compact. 0.98. What is the ratio of the Cost (as % of GNI) in Coal in 1995 to that in 1998?
Your answer should be very brief. 0.8. What is the ratio of the Cost (as % of GNI) in Minerals in 1995 to that in 1998?
Ensure brevity in your answer.  3.22. What is the ratio of the Cost (as % of GNI) of Energy in 1995 to that in 1998?
Provide a succinct answer. 0.9. What is the ratio of the Cost (as % of GNI) in Water in 1995 to that in 1998?
Provide a succinct answer. 1.09. What is the ratio of the Cost (as % of GNI) in Coal in 1995 to that in 1999?
Ensure brevity in your answer.  0.79. What is the ratio of the Cost (as % of GNI) of Minerals in 1995 to that in 1999?
Offer a terse response. 4.16. What is the ratio of the Cost (as % of GNI) in Energy in 1995 to that in 1999?
Ensure brevity in your answer.  1.15. What is the ratio of the Cost (as % of GNI) of Water in 1995 to that in 1999?
Offer a terse response. 1.39. What is the ratio of the Cost (as % of GNI) of Coal in 1995 to that in 2000?
Your response must be concise. 0.68. What is the ratio of the Cost (as % of GNI) in Minerals in 1995 to that in 2000?
Offer a very short reply. 1.55. What is the ratio of the Cost (as % of GNI) of Energy in 1995 to that in 2000?
Ensure brevity in your answer.  0.85. What is the ratio of the Cost (as % of GNI) in Water in 1995 to that in 2000?
Your response must be concise. 1.03. What is the ratio of the Cost (as % of GNI) of Coal in 1995 to that in 2001?
Your answer should be very brief. 0.63. What is the ratio of the Cost (as % of GNI) of Minerals in 1995 to that in 2001?
Provide a short and direct response. 0.63. What is the ratio of the Cost (as % of GNI) of Energy in 1995 to that in 2001?
Your answer should be compact. 0.7. What is the ratio of the Cost (as % of GNI) of Water in 1995 to that in 2001?
Offer a terse response. 0.84. What is the ratio of the Cost (as % of GNI) of Coal in 1995 to that in 2002?
Offer a terse response. 0.68. What is the ratio of the Cost (as % of GNI) in Minerals in 1995 to that in 2002?
Your response must be concise. 0.9. What is the ratio of the Cost (as % of GNI) of Energy in 1995 to that in 2002?
Give a very brief answer. 0.37. What is the ratio of the Cost (as % of GNI) of Water in 1995 to that in 2002?
Give a very brief answer. 0.44. What is the ratio of the Cost (as % of GNI) of Coal in 1995 to that in 2003?
Your response must be concise. 0.8. What is the ratio of the Cost (as % of GNI) of Minerals in 1995 to that in 2003?
Your response must be concise. 1.95. What is the ratio of the Cost (as % of GNI) of Energy in 1995 to that in 2003?
Make the answer very short. 0.35. What is the ratio of the Cost (as % of GNI) in Water in 1995 to that in 2003?
Ensure brevity in your answer.  0.42. What is the ratio of the Cost (as % of GNI) in Coal in 1996 to that in 1997?
Offer a very short reply. 0.89. What is the ratio of the Cost (as % of GNI) in Minerals in 1996 to that in 1997?
Offer a very short reply. 0.88. What is the ratio of the Cost (as % of GNI) in Energy in 1996 to that in 1997?
Offer a terse response. 0.98. What is the ratio of the Cost (as % of GNI) in Water in 1996 to that in 1997?
Make the answer very short. 0.98. What is the ratio of the Cost (as % of GNI) in Coal in 1996 to that in 1998?
Your answer should be compact. 0.88. What is the ratio of the Cost (as % of GNI) of Minerals in 1996 to that in 1998?
Offer a terse response. 0.9. What is the ratio of the Cost (as % of GNI) in Energy in 1996 to that in 1998?
Keep it short and to the point. 1.09. What is the ratio of the Cost (as % of GNI) in Water in 1996 to that in 1998?
Your response must be concise. 1.09. What is the ratio of the Cost (as % of GNI) of Coal in 1996 to that in 1999?
Make the answer very short. 0.87. What is the ratio of the Cost (as % of GNI) of Minerals in 1996 to that in 1999?
Keep it short and to the point. 1.16. What is the ratio of the Cost (as % of GNI) of Energy in 1996 to that in 1999?
Make the answer very short. 1.39. What is the ratio of the Cost (as % of GNI) in Water in 1996 to that in 1999?
Keep it short and to the point. 1.39. What is the ratio of the Cost (as % of GNI) in Coal in 1996 to that in 2000?
Offer a very short reply. 0.74. What is the ratio of the Cost (as % of GNI) of Minerals in 1996 to that in 2000?
Your answer should be compact. 0.43. What is the ratio of the Cost (as % of GNI) of Energy in 1996 to that in 2000?
Keep it short and to the point. 1.04. What is the ratio of the Cost (as % of GNI) in Water in 1996 to that in 2000?
Your answer should be compact. 1.03. What is the ratio of the Cost (as % of GNI) in Coal in 1996 to that in 2001?
Offer a terse response. 0.7. What is the ratio of the Cost (as % of GNI) of Minerals in 1996 to that in 2001?
Provide a succinct answer. 0.18. What is the ratio of the Cost (as % of GNI) in Energy in 1996 to that in 2001?
Your answer should be compact. 0.86. What is the ratio of the Cost (as % of GNI) of Water in 1996 to that in 2001?
Give a very brief answer. 0.84. What is the ratio of the Cost (as % of GNI) of Coal in 1996 to that in 2002?
Offer a very short reply. 0.74. What is the ratio of the Cost (as % of GNI) in Minerals in 1996 to that in 2002?
Provide a short and direct response. 0.25. What is the ratio of the Cost (as % of GNI) in Energy in 1996 to that in 2002?
Your answer should be compact. 0.45. What is the ratio of the Cost (as % of GNI) of Water in 1996 to that in 2002?
Give a very brief answer. 0.44. What is the ratio of the Cost (as % of GNI) in Coal in 1996 to that in 2003?
Your answer should be very brief. 0.87. What is the ratio of the Cost (as % of GNI) of Minerals in 1996 to that in 2003?
Your answer should be compact. 0.54. What is the ratio of the Cost (as % of GNI) in Energy in 1996 to that in 2003?
Keep it short and to the point. 0.42. What is the ratio of the Cost (as % of GNI) in Water in 1996 to that in 2003?
Ensure brevity in your answer.  0.43. What is the ratio of the Cost (as % of GNI) of Minerals in 1997 to that in 1998?
Offer a terse response. 1.02. What is the ratio of the Cost (as % of GNI) of Energy in 1997 to that in 1998?
Your answer should be very brief. 1.11. What is the ratio of the Cost (as % of GNI) in Water in 1997 to that in 1998?
Your response must be concise. 1.11. What is the ratio of the Cost (as % of GNI) in Coal in 1997 to that in 1999?
Provide a short and direct response. 0.98. What is the ratio of the Cost (as % of GNI) of Minerals in 1997 to that in 1999?
Ensure brevity in your answer.  1.32. What is the ratio of the Cost (as % of GNI) of Energy in 1997 to that in 1999?
Your answer should be compact. 1.42. What is the ratio of the Cost (as % of GNI) of Water in 1997 to that in 1999?
Offer a very short reply. 1.42. What is the ratio of the Cost (as % of GNI) of Coal in 1997 to that in 2000?
Offer a terse response. 0.84. What is the ratio of the Cost (as % of GNI) in Minerals in 1997 to that in 2000?
Keep it short and to the point. 0.49. What is the ratio of the Cost (as % of GNI) in Energy in 1997 to that in 2000?
Your answer should be very brief. 1.06. What is the ratio of the Cost (as % of GNI) of Water in 1997 to that in 2000?
Provide a succinct answer. 1.05. What is the ratio of the Cost (as % of GNI) of Coal in 1997 to that in 2001?
Your answer should be compact. 0.78. What is the ratio of the Cost (as % of GNI) of Minerals in 1997 to that in 2001?
Your answer should be very brief. 0.2. What is the ratio of the Cost (as % of GNI) of Energy in 1997 to that in 2001?
Make the answer very short. 0.87. What is the ratio of the Cost (as % of GNI) in Water in 1997 to that in 2001?
Offer a very short reply. 0.86. What is the ratio of the Cost (as % of GNI) of Coal in 1997 to that in 2002?
Provide a succinct answer. 0.84. What is the ratio of the Cost (as % of GNI) in Minerals in 1997 to that in 2002?
Give a very brief answer. 0.28. What is the ratio of the Cost (as % of GNI) in Energy in 1997 to that in 2002?
Offer a very short reply. 0.46. What is the ratio of the Cost (as % of GNI) of Water in 1997 to that in 2002?
Your answer should be compact. 0.45. What is the ratio of the Cost (as % of GNI) of Coal in 1997 to that in 2003?
Give a very brief answer. 0.99. What is the ratio of the Cost (as % of GNI) in Minerals in 1997 to that in 2003?
Offer a terse response. 0.62. What is the ratio of the Cost (as % of GNI) in Energy in 1997 to that in 2003?
Give a very brief answer. 0.43. What is the ratio of the Cost (as % of GNI) in Water in 1997 to that in 2003?
Your answer should be very brief. 0.43. What is the ratio of the Cost (as % of GNI) in Coal in 1998 to that in 1999?
Your answer should be compact. 0.99. What is the ratio of the Cost (as % of GNI) of Minerals in 1998 to that in 1999?
Keep it short and to the point. 1.29. What is the ratio of the Cost (as % of GNI) of Energy in 1998 to that in 1999?
Provide a short and direct response. 1.28. What is the ratio of the Cost (as % of GNI) in Water in 1998 to that in 1999?
Offer a terse response. 1.28. What is the ratio of the Cost (as % of GNI) of Coal in 1998 to that in 2000?
Offer a terse response. 0.84. What is the ratio of the Cost (as % of GNI) in Minerals in 1998 to that in 2000?
Offer a very short reply. 0.48. What is the ratio of the Cost (as % of GNI) in Energy in 1998 to that in 2000?
Provide a succinct answer. 0.95. What is the ratio of the Cost (as % of GNI) of Coal in 1998 to that in 2001?
Provide a short and direct response. 0.79. What is the ratio of the Cost (as % of GNI) in Minerals in 1998 to that in 2001?
Make the answer very short. 0.2. What is the ratio of the Cost (as % of GNI) in Energy in 1998 to that in 2001?
Your response must be concise. 0.79. What is the ratio of the Cost (as % of GNI) of Water in 1998 to that in 2001?
Make the answer very short. 0.77. What is the ratio of the Cost (as % of GNI) of Coal in 1998 to that in 2002?
Provide a short and direct response. 0.84. What is the ratio of the Cost (as % of GNI) in Minerals in 1998 to that in 2002?
Offer a terse response. 0.28. What is the ratio of the Cost (as % of GNI) of Energy in 1998 to that in 2002?
Your answer should be compact. 0.41. What is the ratio of the Cost (as % of GNI) in Water in 1998 to that in 2002?
Give a very brief answer. 0.41. What is the ratio of the Cost (as % of GNI) of Coal in 1998 to that in 2003?
Your answer should be compact. 0.99. What is the ratio of the Cost (as % of GNI) in Minerals in 1998 to that in 2003?
Offer a terse response. 0.6. What is the ratio of the Cost (as % of GNI) in Energy in 1998 to that in 2003?
Your response must be concise. 0.39. What is the ratio of the Cost (as % of GNI) of Water in 1998 to that in 2003?
Offer a very short reply. 0.39. What is the ratio of the Cost (as % of GNI) in Coal in 1999 to that in 2000?
Your answer should be very brief. 0.85. What is the ratio of the Cost (as % of GNI) of Minerals in 1999 to that in 2000?
Make the answer very short. 0.37. What is the ratio of the Cost (as % of GNI) in Energy in 1999 to that in 2000?
Offer a very short reply. 0.74. What is the ratio of the Cost (as % of GNI) of Water in 1999 to that in 2000?
Your response must be concise. 0.74. What is the ratio of the Cost (as % of GNI) of Coal in 1999 to that in 2001?
Provide a succinct answer. 0.8. What is the ratio of the Cost (as % of GNI) of Minerals in 1999 to that in 2001?
Offer a terse response. 0.15. What is the ratio of the Cost (as % of GNI) in Energy in 1999 to that in 2001?
Give a very brief answer. 0.61. What is the ratio of the Cost (as % of GNI) of Water in 1999 to that in 2001?
Your response must be concise. 0.6. What is the ratio of the Cost (as % of GNI) of Coal in 1999 to that in 2002?
Make the answer very short. 0.85. What is the ratio of the Cost (as % of GNI) in Minerals in 1999 to that in 2002?
Offer a very short reply. 0.22. What is the ratio of the Cost (as % of GNI) in Energy in 1999 to that in 2002?
Offer a very short reply. 0.32. What is the ratio of the Cost (as % of GNI) of Water in 1999 to that in 2002?
Your response must be concise. 0.32. What is the ratio of the Cost (as % of GNI) in Coal in 1999 to that in 2003?
Provide a succinct answer. 1. What is the ratio of the Cost (as % of GNI) in Minerals in 1999 to that in 2003?
Give a very brief answer. 0.47. What is the ratio of the Cost (as % of GNI) in Energy in 1999 to that in 2003?
Keep it short and to the point. 0.3. What is the ratio of the Cost (as % of GNI) in Water in 1999 to that in 2003?
Keep it short and to the point. 0.31. What is the ratio of the Cost (as % of GNI) in Coal in 2000 to that in 2001?
Provide a succinct answer. 0.94. What is the ratio of the Cost (as % of GNI) in Minerals in 2000 to that in 2001?
Offer a terse response. 0.41. What is the ratio of the Cost (as % of GNI) in Energy in 2000 to that in 2001?
Provide a succinct answer. 0.83. What is the ratio of the Cost (as % of GNI) of Water in 2000 to that in 2001?
Offer a terse response. 0.82. What is the ratio of the Cost (as % of GNI) in Minerals in 2000 to that in 2002?
Make the answer very short. 0.58. What is the ratio of the Cost (as % of GNI) of Energy in 2000 to that in 2002?
Provide a succinct answer. 0.43. What is the ratio of the Cost (as % of GNI) in Water in 2000 to that in 2002?
Your response must be concise. 0.43. What is the ratio of the Cost (as % of GNI) of Coal in 2000 to that in 2003?
Your answer should be very brief. 1.18. What is the ratio of the Cost (as % of GNI) of Minerals in 2000 to that in 2003?
Your answer should be compact. 1.26. What is the ratio of the Cost (as % of GNI) of Energy in 2000 to that in 2003?
Your answer should be compact. 0.41. What is the ratio of the Cost (as % of GNI) in Water in 2000 to that in 2003?
Provide a succinct answer. 0.41. What is the ratio of the Cost (as % of GNI) of Coal in 2001 to that in 2002?
Your answer should be very brief. 1.07. What is the ratio of the Cost (as % of GNI) in Minerals in 2001 to that in 2002?
Give a very brief answer. 1.42. What is the ratio of the Cost (as % of GNI) of Energy in 2001 to that in 2002?
Offer a terse response. 0.52. What is the ratio of the Cost (as % of GNI) of Water in 2001 to that in 2002?
Keep it short and to the point. 0.53. What is the ratio of the Cost (as % of GNI) in Coal in 2001 to that in 2003?
Your response must be concise. 1.26. What is the ratio of the Cost (as % of GNI) in Minerals in 2001 to that in 2003?
Ensure brevity in your answer.  3.09. What is the ratio of the Cost (as % of GNI) in Energy in 2001 to that in 2003?
Offer a very short reply. 0.5. What is the ratio of the Cost (as % of GNI) in Water in 2001 to that in 2003?
Keep it short and to the point. 0.51. What is the ratio of the Cost (as % of GNI) in Coal in 2002 to that in 2003?
Your answer should be very brief. 1.18. What is the ratio of the Cost (as % of GNI) of Minerals in 2002 to that in 2003?
Offer a very short reply. 2.17. What is the ratio of the Cost (as % of GNI) of Energy in 2002 to that in 2003?
Give a very brief answer. 0.95. What is the ratio of the Cost (as % of GNI) in Water in 2002 to that in 2003?
Keep it short and to the point. 0.96. What is the difference between the highest and the second highest Cost (as % of GNI) of Coal?
Make the answer very short. 0.02. What is the difference between the highest and the second highest Cost (as % of GNI) in Minerals?
Offer a terse response. 0. What is the difference between the highest and the second highest Cost (as % of GNI) of Energy?
Your answer should be compact. 0.03. What is the difference between the highest and the second highest Cost (as % of GNI) in Water?
Make the answer very short. 0.03. What is the difference between the highest and the lowest Cost (as % of GNI) in Coal?
Offer a terse response. 0.11. What is the difference between the highest and the lowest Cost (as % of GNI) in Minerals?
Offer a very short reply. 0.01. What is the difference between the highest and the lowest Cost (as % of GNI) of Energy?
Ensure brevity in your answer.  0.42. What is the difference between the highest and the lowest Cost (as % of GNI) of Water?
Your answer should be very brief. 0.42. 